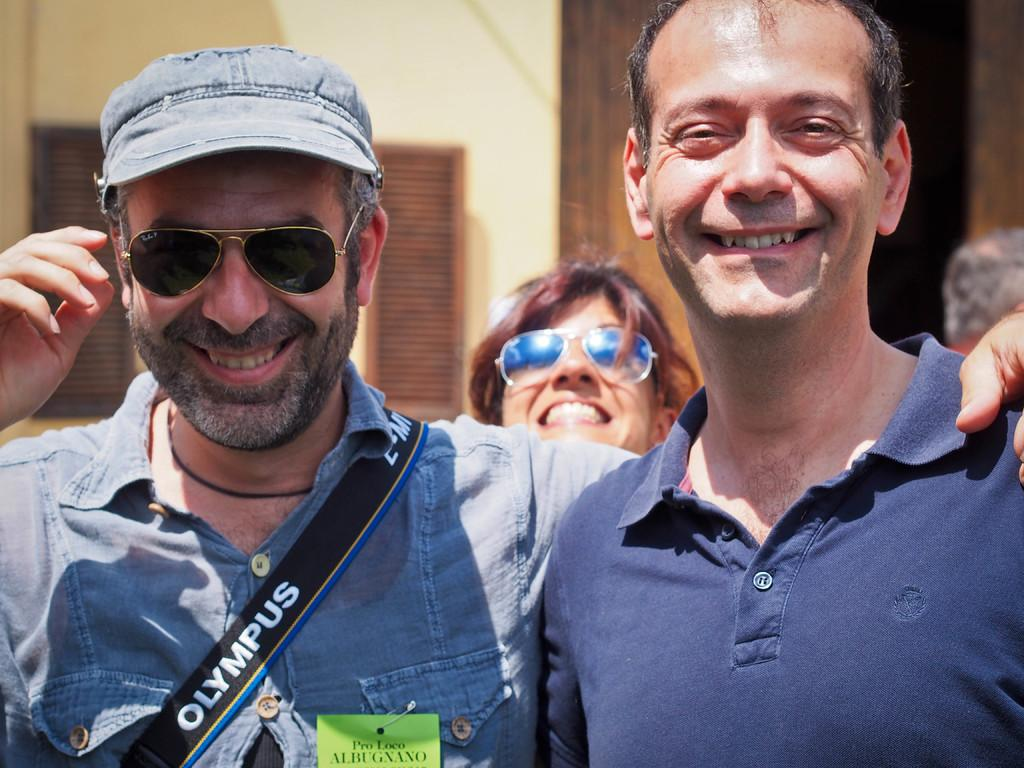How many people are in the image? There are three persons standing in the image. What is the facial expression of the persons in the image? The persons are smiling. What can be seen in the background of the image? There is a building and a person in the background of the image. What is present on the left side of the image? There are window blinds on the left side of the image. What type of chickens are causing trouble in the background of the image? There are no chickens present in the image, so it is not possible to determine if they are causing trouble or not. 